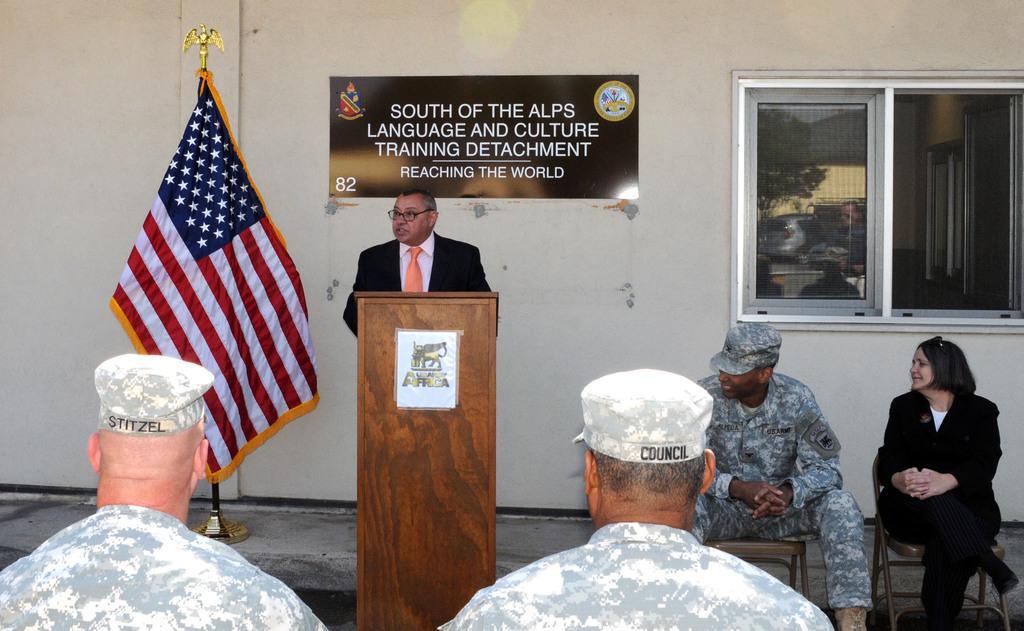Describe this image in one or two sentences. In this image I can see the group of people among them, a man is standing in front of a podium and others are sitting on a chair. I can also see there is flag and a window. 